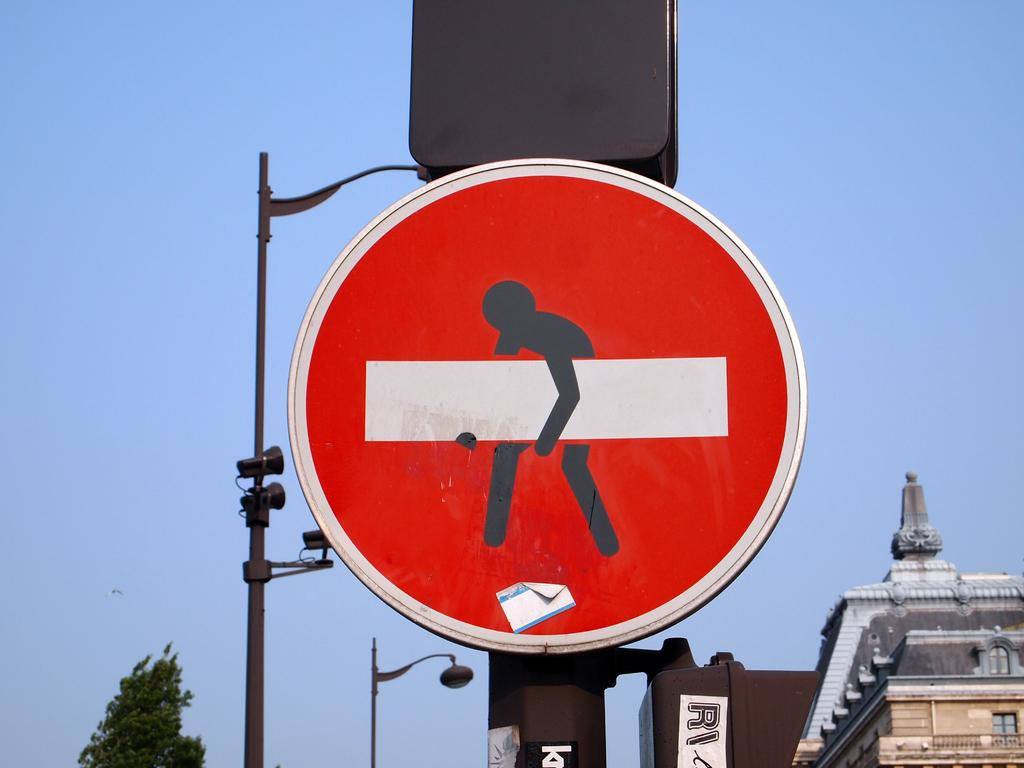What is attached to the pole in the image? There is a board attached to a pole in the image. What can be found on the board? The board has text and a picture on it. What can be seen in the background of the image? There is a building, a street pole, a tree, and the sky visible in the background. How does the sky appear in the image? The sky appears cloudy in the image. Can you tell me how many carpenters are working on the gate in the image? There is no gate or carpenters present in the image. What type of fall can be seen in the image? There is no fall or any indication of a fall in the image. 